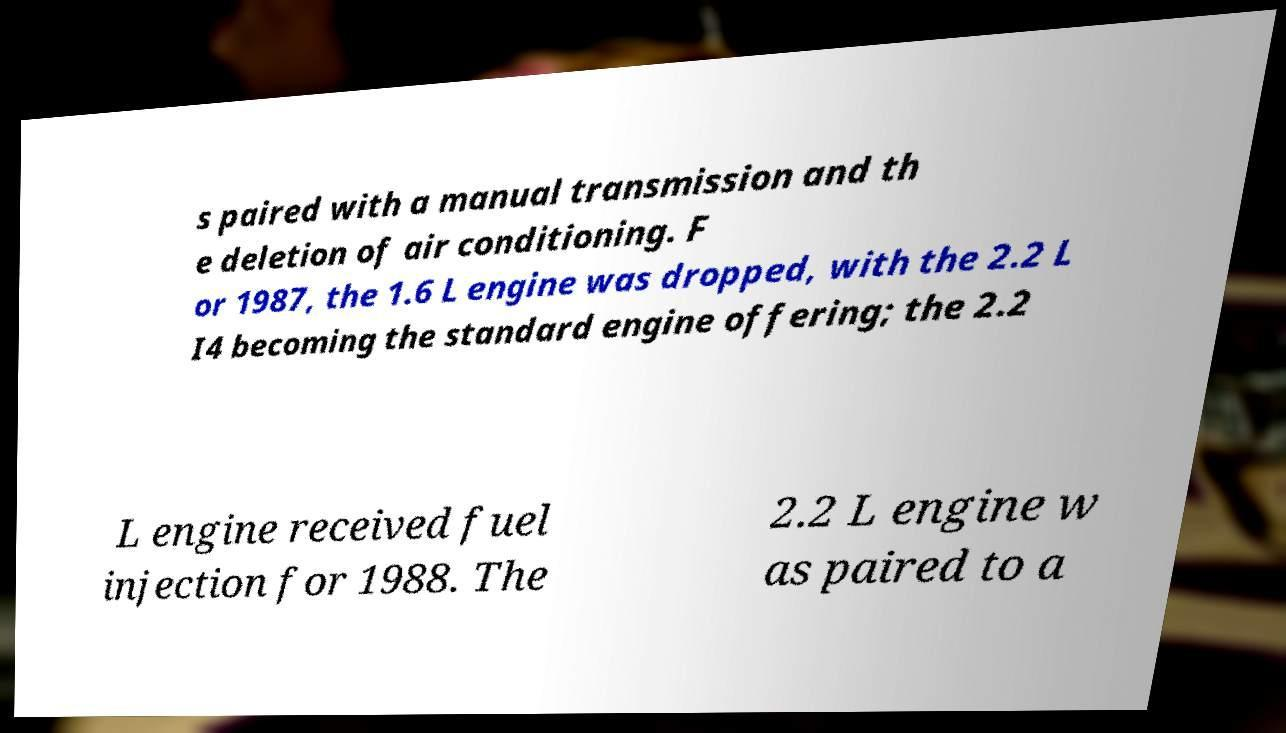I need the written content from this picture converted into text. Can you do that? s paired with a manual transmission and th e deletion of air conditioning. F or 1987, the 1.6 L engine was dropped, with the 2.2 L I4 becoming the standard engine offering; the 2.2 L engine received fuel injection for 1988. The 2.2 L engine w as paired to a 